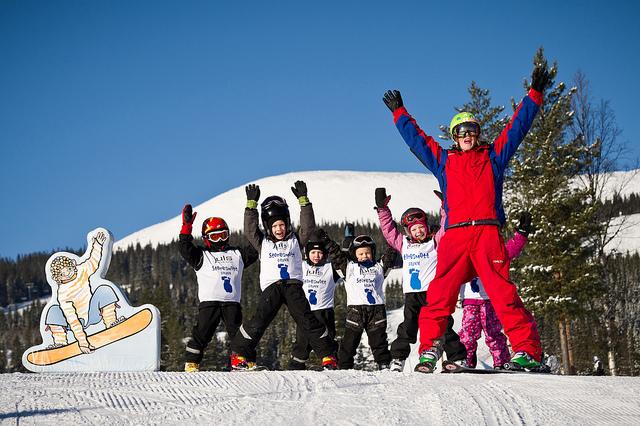Are there children in the picture?
Keep it brief. Yes. Are all the snowboarders real?
Short answer required. No. What are the skiers celebrating?
Be succinct. Victory. Are any of the people children?
Be succinct. Yes. 